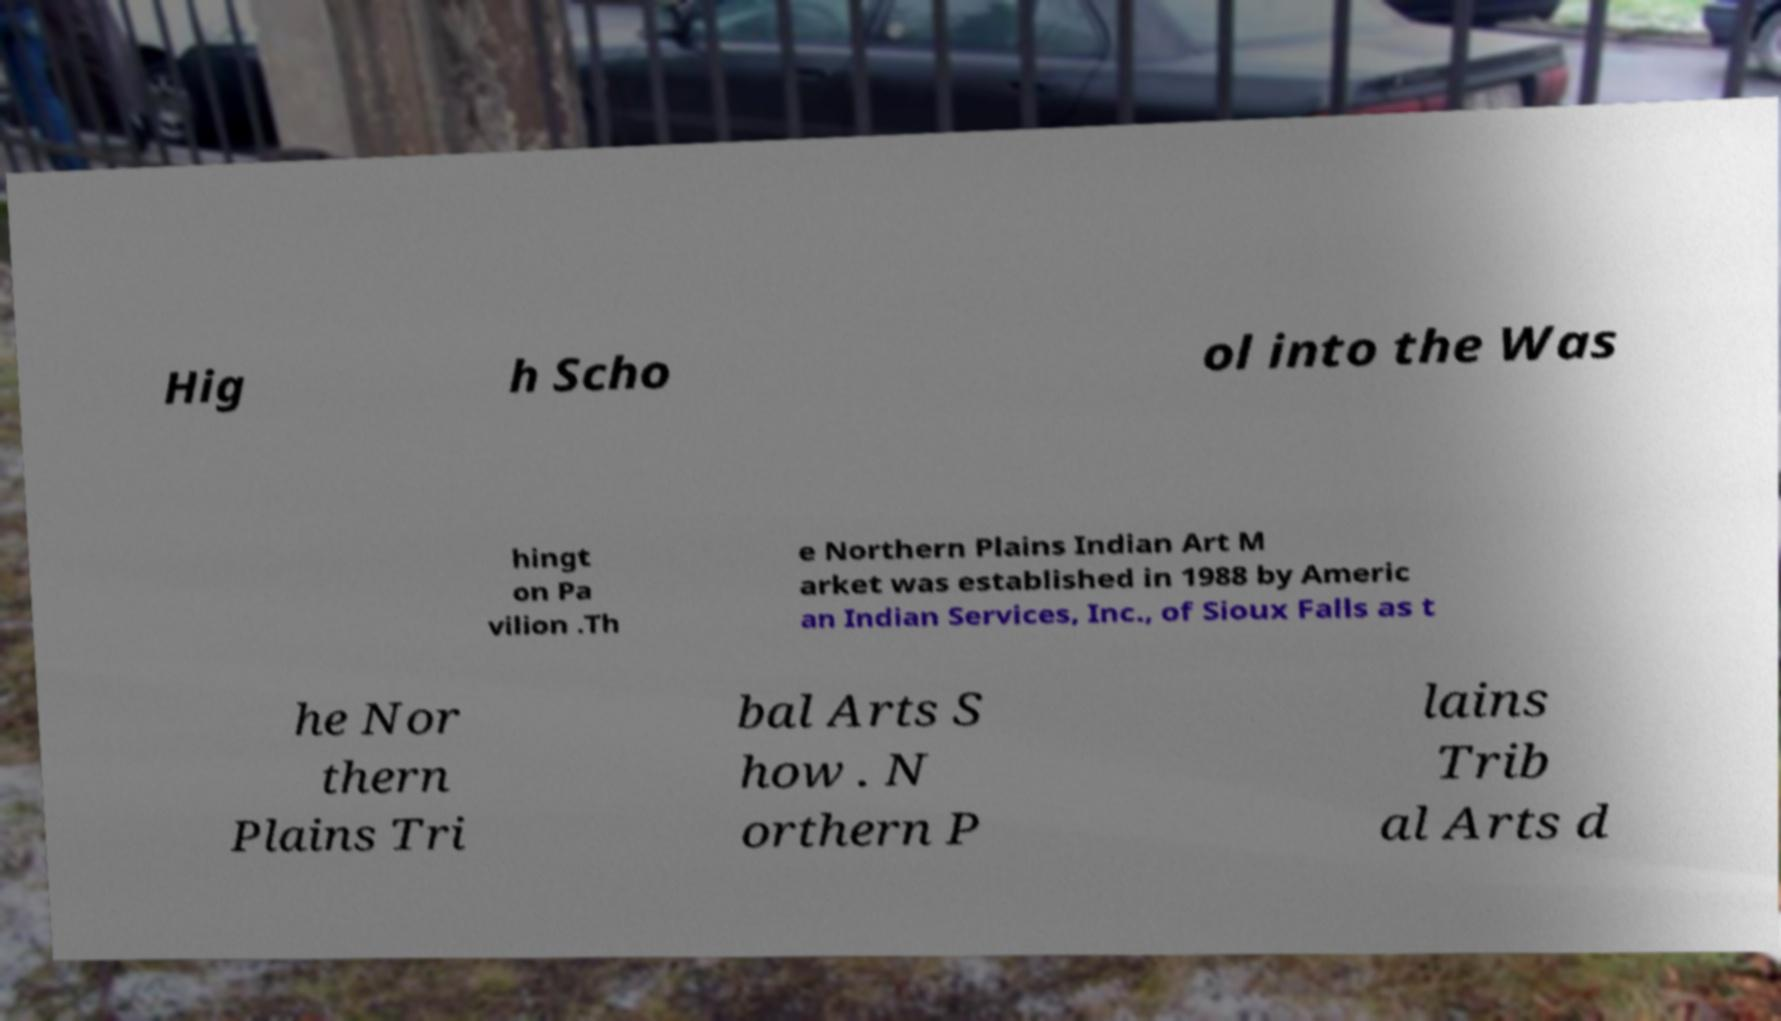Could you assist in decoding the text presented in this image and type it out clearly? Hig h Scho ol into the Was hingt on Pa vilion .Th e Northern Plains Indian Art M arket was established in 1988 by Americ an Indian Services, Inc., of Sioux Falls as t he Nor thern Plains Tri bal Arts S how . N orthern P lains Trib al Arts d 